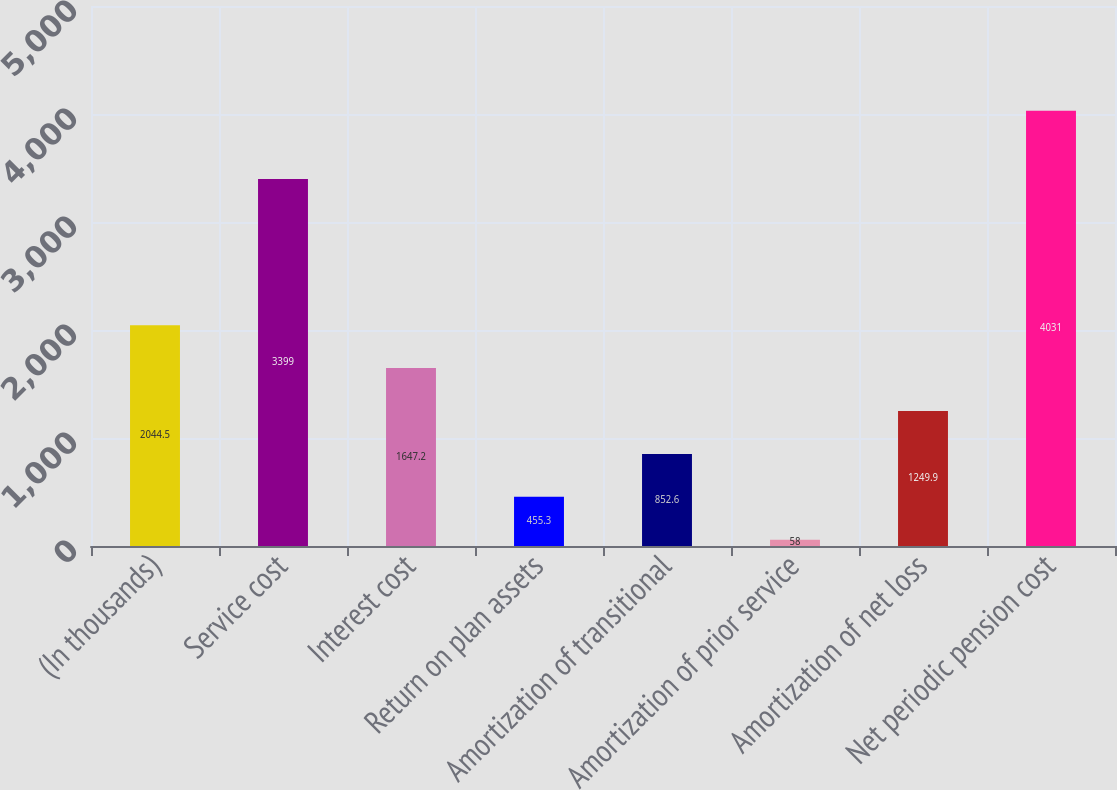<chart> <loc_0><loc_0><loc_500><loc_500><bar_chart><fcel>(In thousands)<fcel>Service cost<fcel>Interest cost<fcel>Return on plan assets<fcel>Amortization of transitional<fcel>Amortization of prior service<fcel>Amortization of net loss<fcel>Net periodic pension cost<nl><fcel>2044.5<fcel>3399<fcel>1647.2<fcel>455.3<fcel>852.6<fcel>58<fcel>1249.9<fcel>4031<nl></chart> 